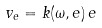<formula> <loc_0><loc_0><loc_500><loc_500>v _ { e } = k ( \omega , e ) \, e</formula> 